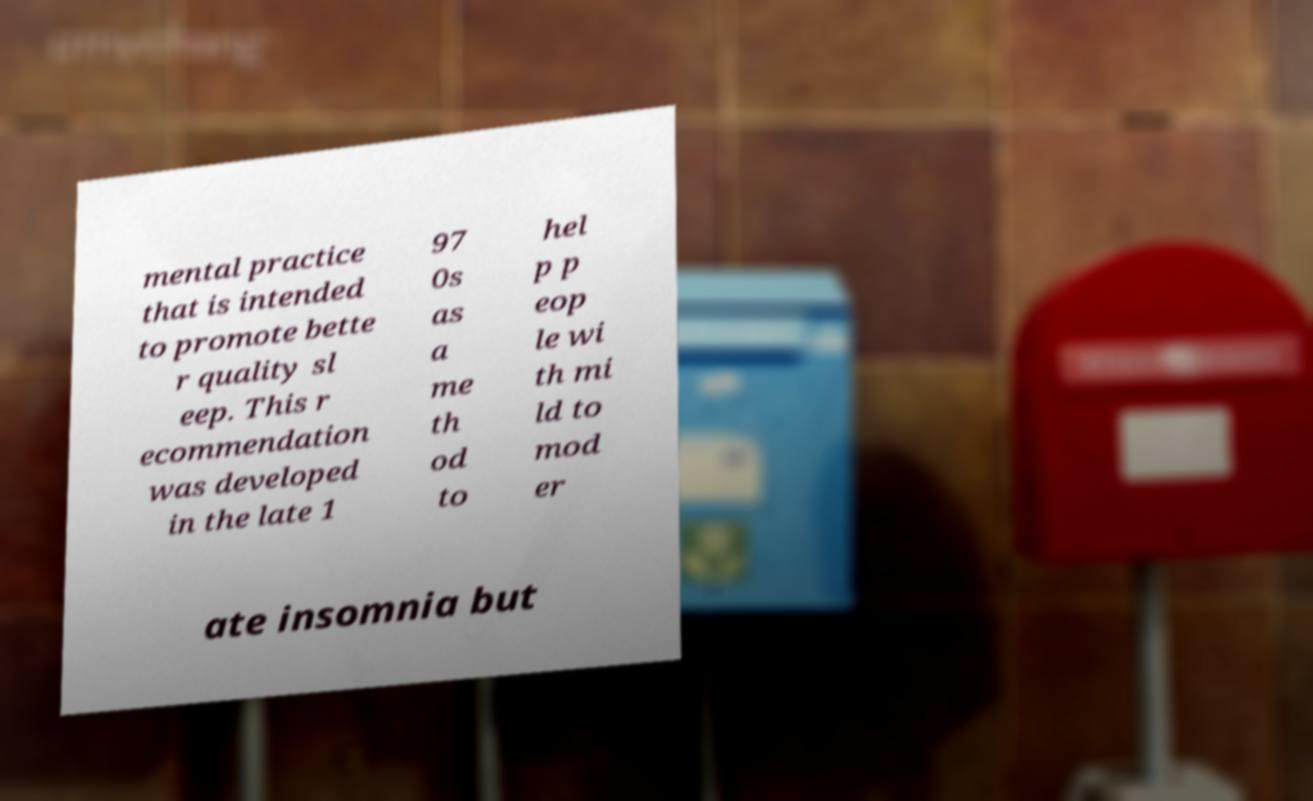Please identify and transcribe the text found in this image. mental practice that is intended to promote bette r quality sl eep. This r ecommendation was developed in the late 1 97 0s as a me th od to hel p p eop le wi th mi ld to mod er ate insomnia but 